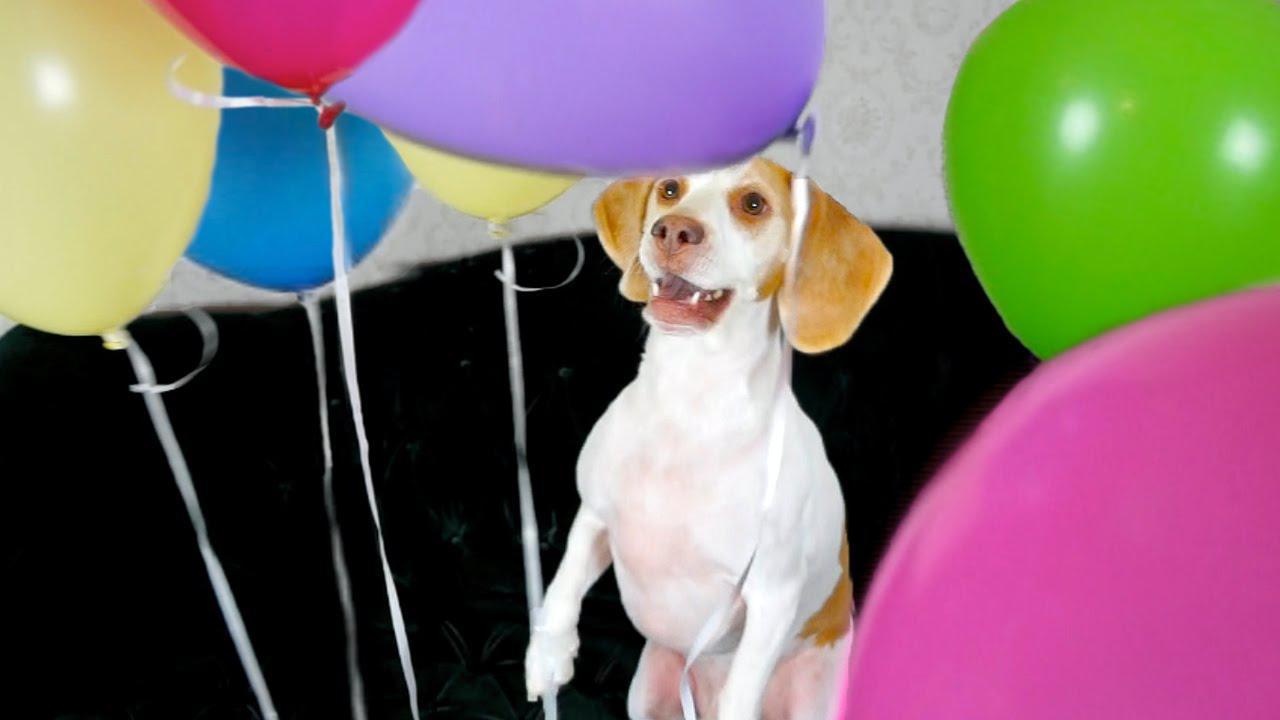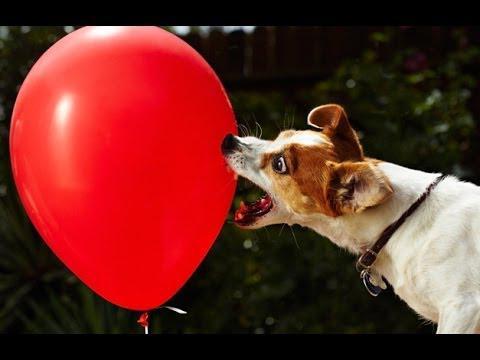The first image is the image on the left, the second image is the image on the right. Considering the images on both sides, is "There is exactly one dog in the right image." valid? Answer yes or no. Yes. 